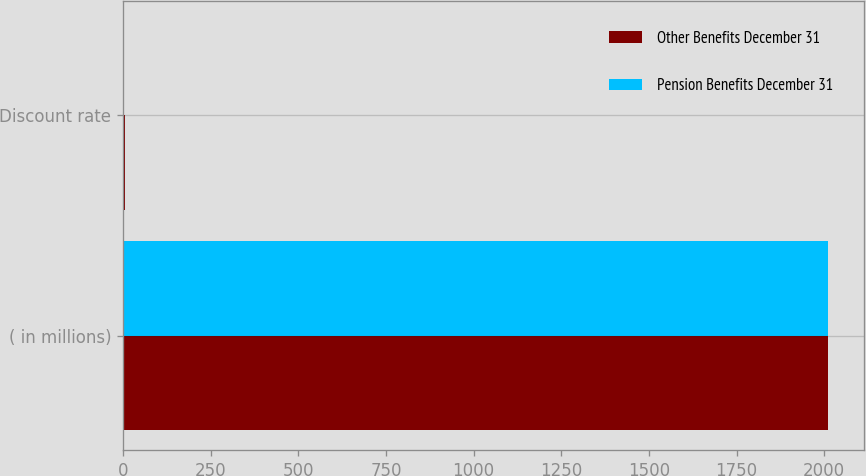Convert chart to OTSL. <chart><loc_0><loc_0><loc_500><loc_500><stacked_bar_chart><ecel><fcel>( in millions)<fcel>Discount rate<nl><fcel>Other Benefits December 31<fcel>2012<fcel>4.24<nl><fcel>Pension Benefits December 31<fcel>2012<fcel>4.04<nl></chart> 